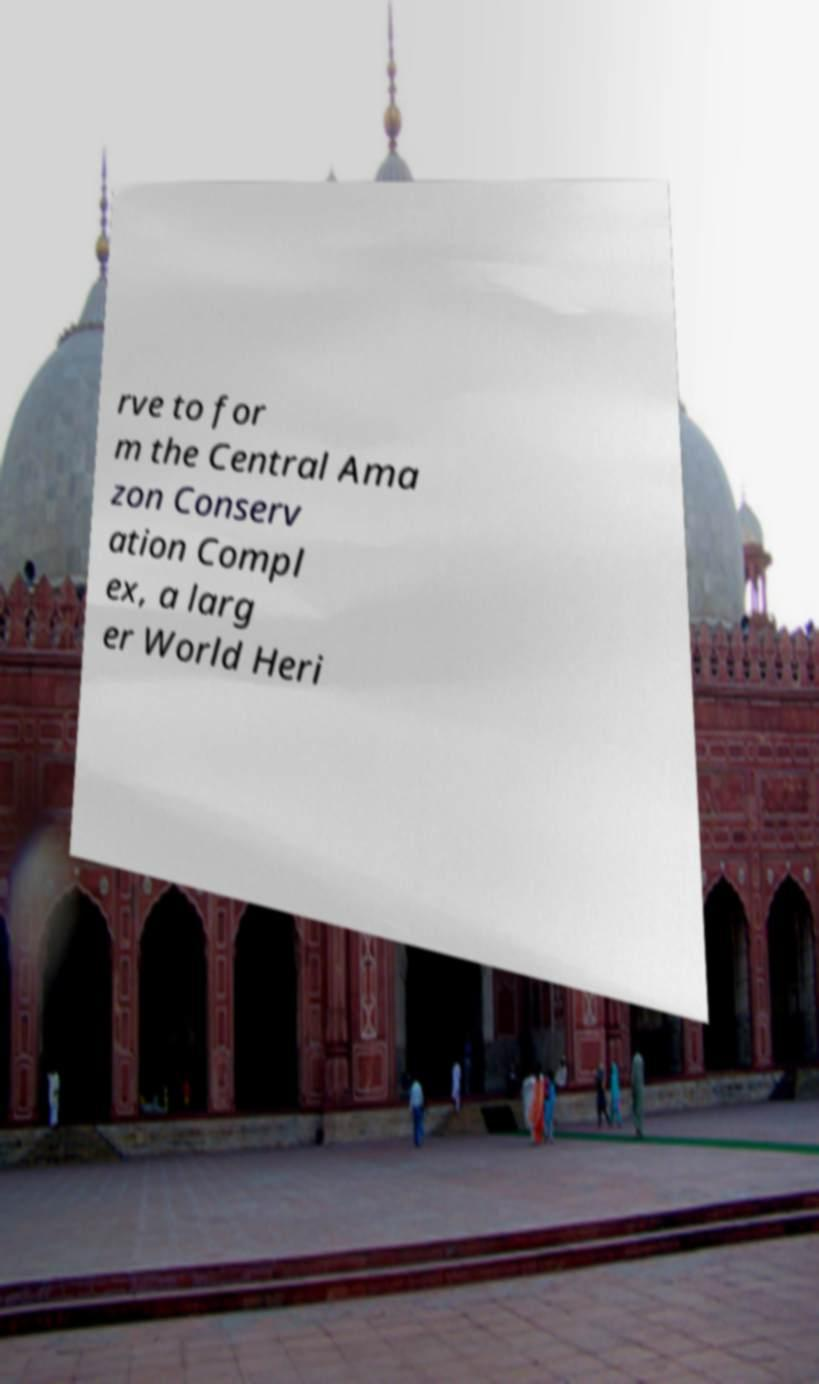I need the written content from this picture converted into text. Can you do that? rve to for m the Central Ama zon Conserv ation Compl ex, a larg er World Heri 